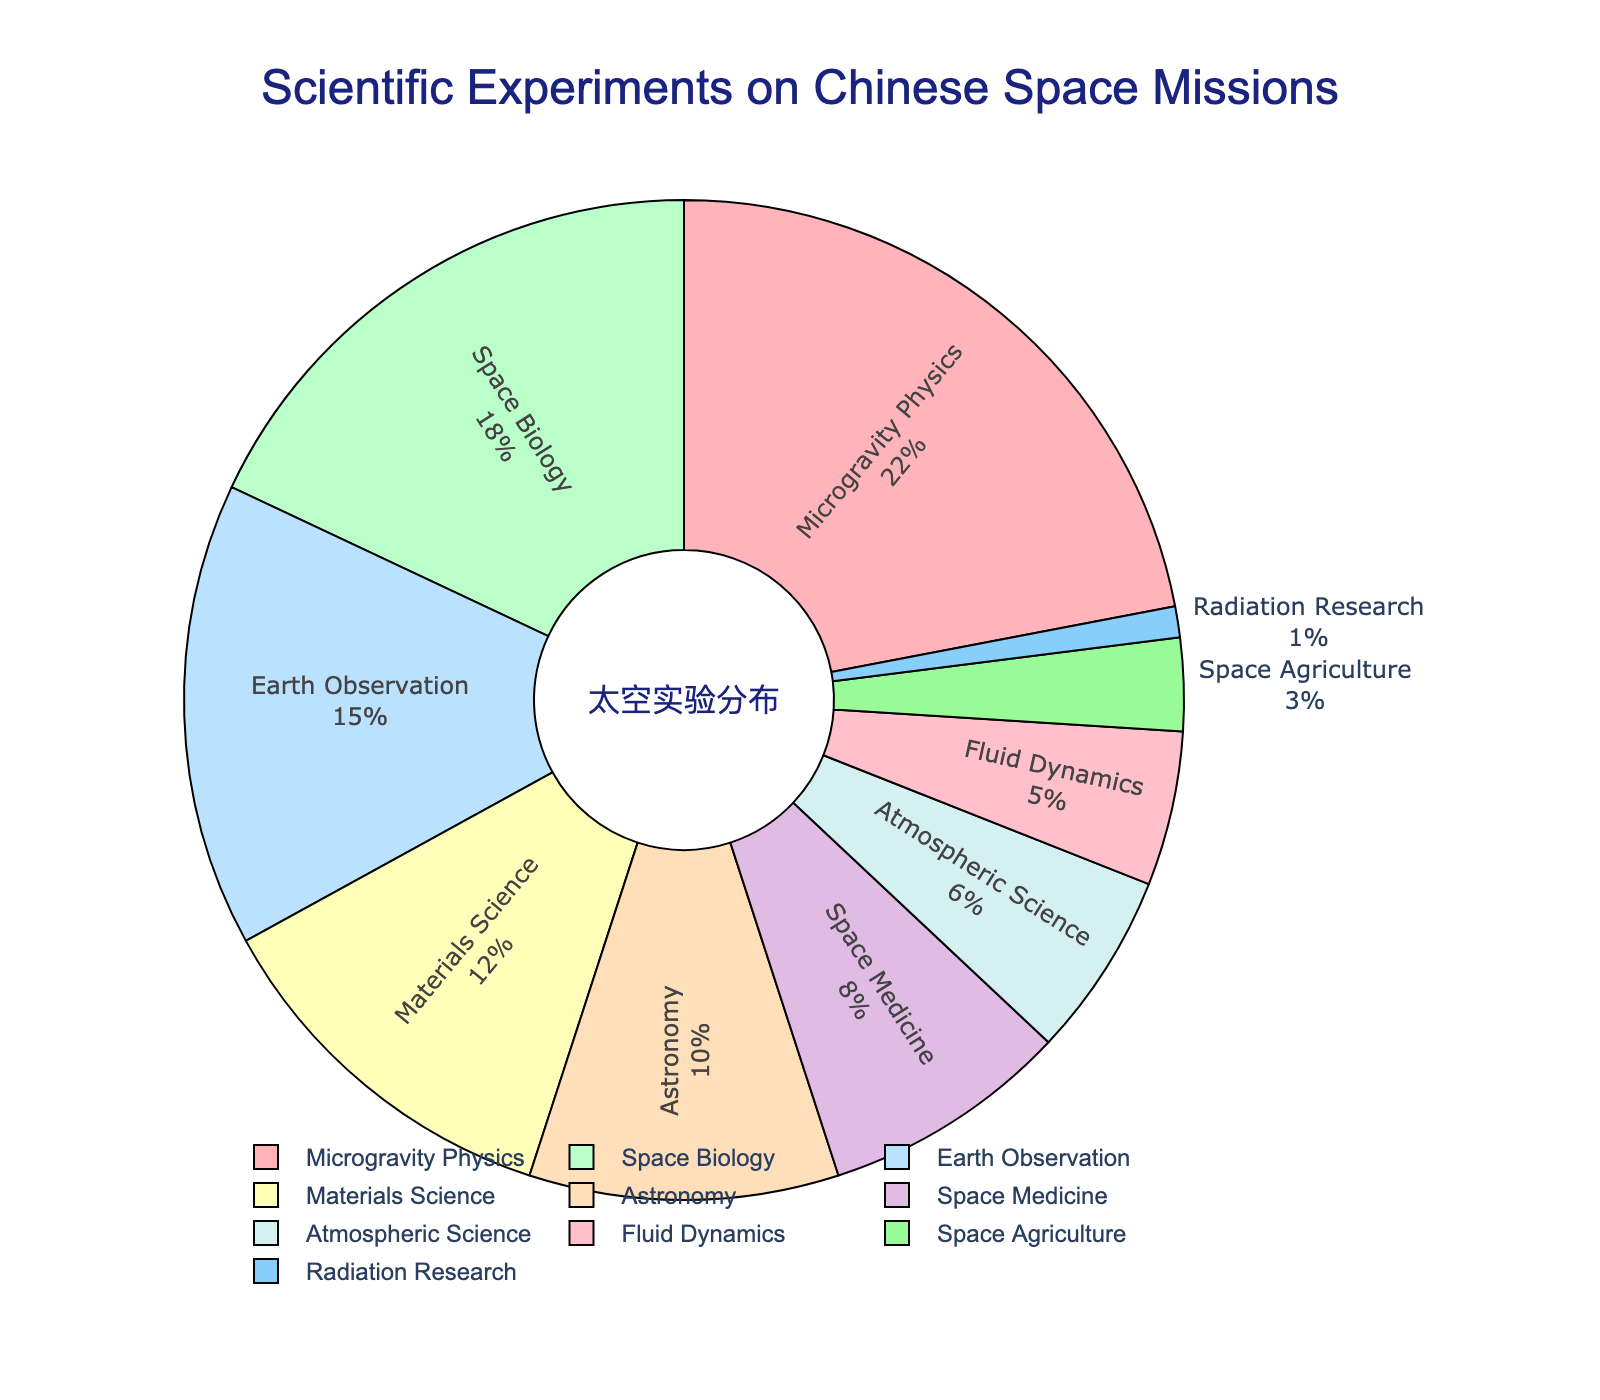What's the largest category of scientific experiments on Chinese space missions? The largest segment on the pie chart is Microgravity Physics, which accounts for 22% of the experiments.
Answer: Microgravity Physics Which two categories together make up 30% of the scientific experiments? Space Biology (18%) and Space Medicine (8%) together make up 26%. To reach 30%, we need to include another category such as Space Agriculture (3%) for a total of 29%. A correct 30% would include Space Biology (18%) and Earth Observation (15%) totaling (18 + 15 = 33) so Earth Observation and Microgravity Physics
Answer: Earth Observation and Microgravity Physics Which category has the smallest percentage of experiments, and what's its value? The smallest segment on the pie chart is Radiation Research, which accounts for 1% of the experiments.
Answer: Radiation Research, 1% Is the percentage of Space Medicine greater than that of Astronomy? Yes, Space Medicine accounts for 8% of the experiments, while Astronomy accounts for 10%.
Answer: No How much more percentage does Microgravity Physics have compared to Space Biology? Microgravity Physics accounts for 22% and Space Biology accounts for 18%. The difference is 22% - 18% = 4%.
Answer: 4% What is the combined percentage of Space Biology, Earth Observation, and Materials Science? Adding together the percentages: Space Biology (18%) + Earth Observation (15%) + Materials Science (12%) = 18 + 15 + 12 = 45%.
Answer: 45% Which has a larger percentage: Atmospheric Science or Fluid Dynamics, and by how much? Atmospheric Science accounts for 6% of the experiments, while Fluid Dynamics accounts for 5%. The difference is 6% - 5% = 1%.
Answer: Atmospheric Science by 1% Which categories combined make up more than half of the total experiments? Combining percentages, the largest categories are Microgravity Physics (22%) + Space Biology (18%) + Earth Observation (15%) = 55%, which is more than half.
Answer: Microgravity Physics, Space Biology, Earth Observation What is the total percentage of categories with less than 10% each? Adding the percentages: Astronomy (10%), Space Medicine (8%), Atmospheric Science (6%), Fluid Dynamics (5%), Space Agriculture (3%), Radiation Research (1%) = 10 + 8 + 6 + 5 + 3 + 1 = 33%.
Answer: 33% 